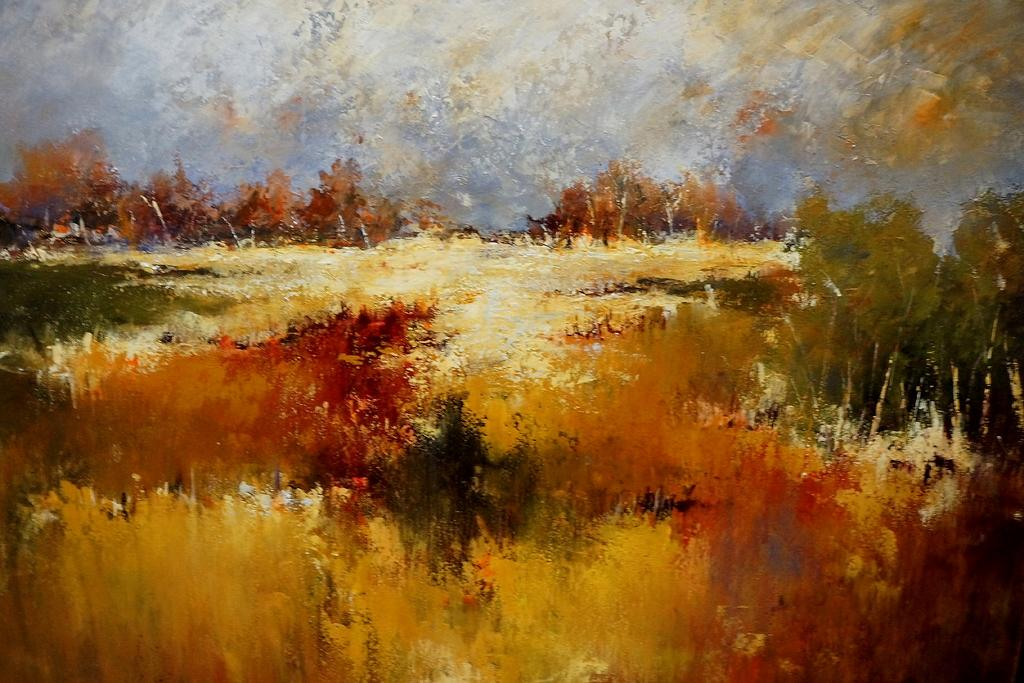What type of artwork is depicted in the image? The image is a painting. What can be seen in the center of the painting? There are trees, plants, and grass in the center of the image. How many cars are parked in the center of the image? There are no cars present in the image; it features a painting with trees, plants, and grass in the center. What force is being applied to the screw in the center of the image? There is no screw present in the image; it features a painting with trees, plants, and grass in the center. 